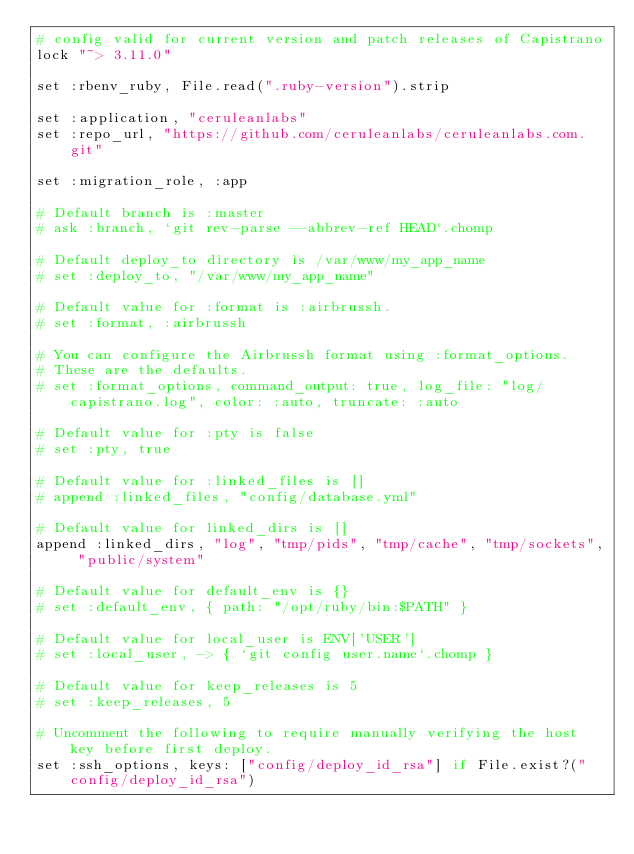<code> <loc_0><loc_0><loc_500><loc_500><_Ruby_># config valid for current version and patch releases of Capistrano
lock "~> 3.11.0"

set :rbenv_ruby, File.read(".ruby-version").strip

set :application, "ceruleanlabs"
set :repo_url, "https://github.com/ceruleanlabs/ceruleanlabs.com.git"

set :migration_role, :app

# Default branch is :master
# ask :branch, `git rev-parse --abbrev-ref HEAD`.chomp

# Default deploy_to directory is /var/www/my_app_name
# set :deploy_to, "/var/www/my_app_name"

# Default value for :format is :airbrussh.
# set :format, :airbrussh

# You can configure the Airbrussh format using :format_options.
# These are the defaults.
# set :format_options, command_output: true, log_file: "log/capistrano.log", color: :auto, truncate: :auto

# Default value for :pty is false
# set :pty, true

# Default value for :linked_files is []
# append :linked_files, "config/database.yml"

# Default value for linked_dirs is []
append :linked_dirs, "log", "tmp/pids", "tmp/cache", "tmp/sockets", "public/system"

# Default value for default_env is {}
# set :default_env, { path: "/opt/ruby/bin:$PATH" }

# Default value for local_user is ENV['USER']
# set :local_user, -> { `git config user.name`.chomp }

# Default value for keep_releases is 5
# set :keep_releases, 5

# Uncomment the following to require manually verifying the host key before first deploy.
set :ssh_options, keys: ["config/deploy_id_rsa"] if File.exist?("config/deploy_id_rsa")
</code> 